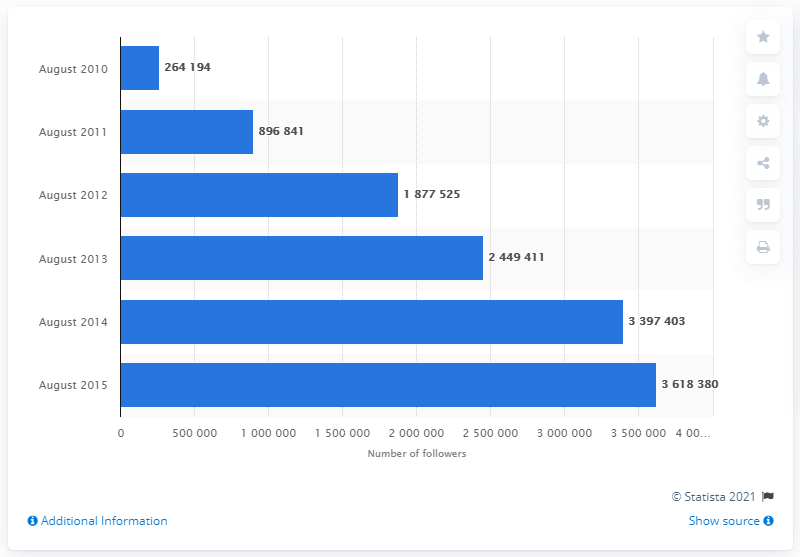Specify some key components in this picture. In August 2010, ASOS had 264,194 Facebook followers. In August 2015, ASOS had approximately 3618380 Facebook followers. 